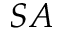Convert formula to latex. <formula><loc_0><loc_0><loc_500><loc_500>S A</formula> 